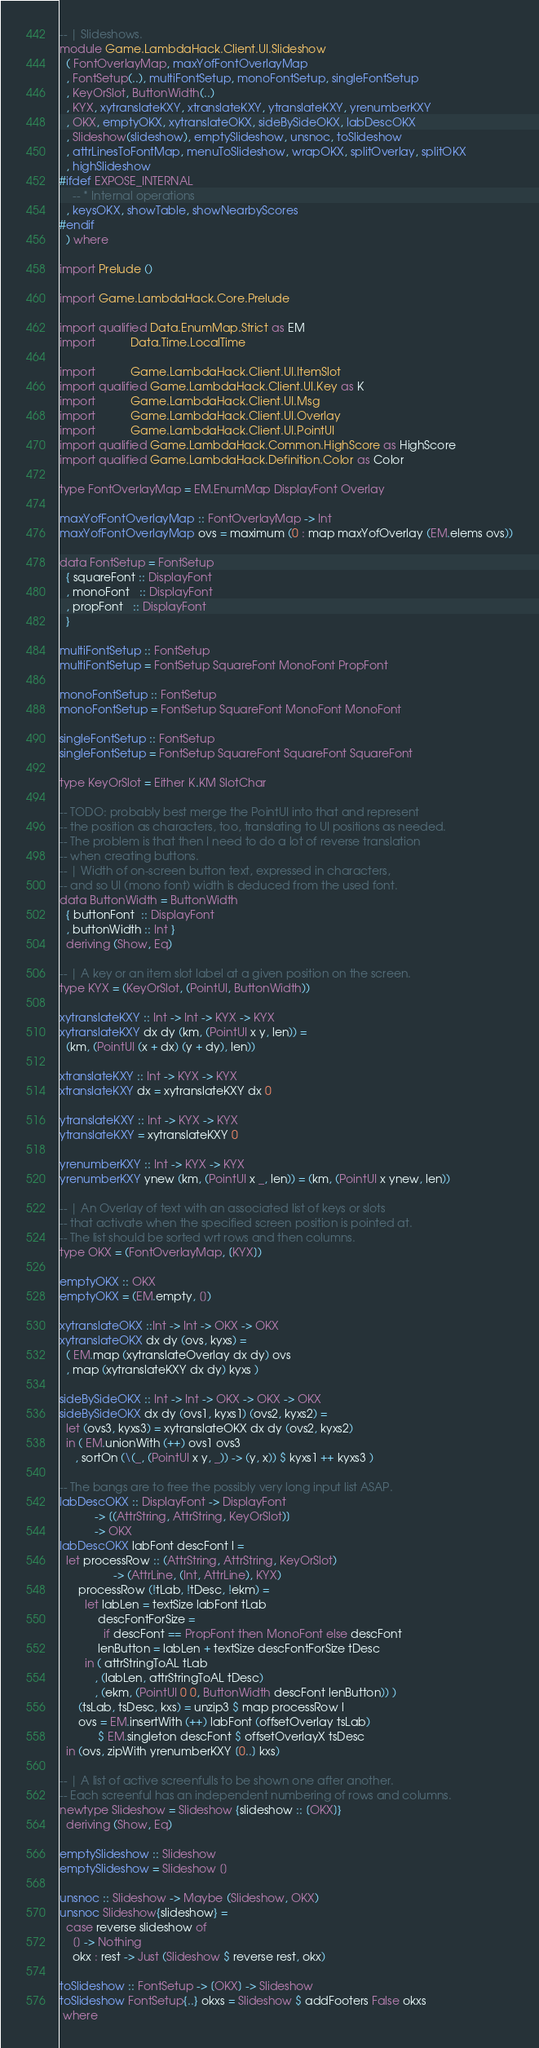Convert code to text. <code><loc_0><loc_0><loc_500><loc_500><_Haskell_>-- | Slideshows.
module Game.LambdaHack.Client.UI.Slideshow
  ( FontOverlayMap, maxYofFontOverlayMap
  , FontSetup(..), multiFontSetup, monoFontSetup, singleFontSetup
  , KeyOrSlot, ButtonWidth(..)
  , KYX, xytranslateKXY, xtranslateKXY, ytranslateKXY, yrenumberKXY
  , OKX, emptyOKX, xytranslateOKX, sideBySideOKX, labDescOKX
  , Slideshow(slideshow), emptySlideshow, unsnoc, toSlideshow
  , attrLinesToFontMap, menuToSlideshow, wrapOKX, splitOverlay, splitOKX
  , highSlideshow
#ifdef EXPOSE_INTERNAL
    -- * Internal operations
  , keysOKX, showTable, showNearbyScores
#endif
  ) where

import Prelude ()

import Game.LambdaHack.Core.Prelude

import qualified Data.EnumMap.Strict as EM
import           Data.Time.LocalTime

import           Game.LambdaHack.Client.UI.ItemSlot
import qualified Game.LambdaHack.Client.UI.Key as K
import           Game.LambdaHack.Client.UI.Msg
import           Game.LambdaHack.Client.UI.Overlay
import           Game.LambdaHack.Client.UI.PointUI
import qualified Game.LambdaHack.Common.HighScore as HighScore
import qualified Game.LambdaHack.Definition.Color as Color

type FontOverlayMap = EM.EnumMap DisplayFont Overlay

maxYofFontOverlayMap :: FontOverlayMap -> Int
maxYofFontOverlayMap ovs = maximum (0 : map maxYofOverlay (EM.elems ovs))

data FontSetup = FontSetup
  { squareFont :: DisplayFont
  , monoFont   :: DisplayFont
  , propFont   :: DisplayFont
  }

multiFontSetup :: FontSetup
multiFontSetup = FontSetup SquareFont MonoFont PropFont

monoFontSetup :: FontSetup
monoFontSetup = FontSetup SquareFont MonoFont MonoFont

singleFontSetup :: FontSetup
singleFontSetup = FontSetup SquareFont SquareFont SquareFont

type KeyOrSlot = Either K.KM SlotChar

-- TODO: probably best merge the PointUI into that and represent
-- the position as characters, too, translating to UI positions as needed.
-- The problem is that then I need to do a lot of reverse translation
-- when creating buttons.
-- | Width of on-screen button text, expressed in characters,
-- and so UI (mono font) width is deduced from the used font.
data ButtonWidth = ButtonWidth
  { buttonFont  :: DisplayFont
  , buttonWidth :: Int }
  deriving (Show, Eq)

-- | A key or an item slot label at a given position on the screen.
type KYX = (KeyOrSlot, (PointUI, ButtonWidth))

xytranslateKXY :: Int -> Int -> KYX -> KYX
xytranslateKXY dx dy (km, (PointUI x y, len)) =
  (km, (PointUI (x + dx) (y + dy), len))

xtranslateKXY :: Int -> KYX -> KYX
xtranslateKXY dx = xytranslateKXY dx 0

ytranslateKXY :: Int -> KYX -> KYX
ytranslateKXY = xytranslateKXY 0

yrenumberKXY :: Int -> KYX -> KYX
yrenumberKXY ynew (km, (PointUI x _, len)) = (km, (PointUI x ynew, len))

-- | An Overlay of text with an associated list of keys or slots
-- that activate when the specified screen position is pointed at.
-- The list should be sorted wrt rows and then columns.
type OKX = (FontOverlayMap, [KYX])

emptyOKX :: OKX
emptyOKX = (EM.empty, [])

xytranslateOKX ::Int -> Int -> OKX -> OKX
xytranslateOKX dx dy (ovs, kyxs) =
  ( EM.map (xytranslateOverlay dx dy) ovs
  , map (xytranslateKXY dx dy) kyxs )

sideBySideOKX :: Int -> Int -> OKX -> OKX -> OKX
sideBySideOKX dx dy (ovs1, kyxs1) (ovs2, kyxs2) =
  let (ovs3, kyxs3) = xytranslateOKX dx dy (ovs2, kyxs2)
  in ( EM.unionWith (++) ovs1 ovs3
     , sortOn (\(_, (PointUI x y, _)) -> (y, x)) $ kyxs1 ++ kyxs3 )

-- The bangs are to free the possibly very long input list ASAP.
labDescOKX :: DisplayFont -> DisplayFont
           -> [(AttrString, AttrString, KeyOrSlot)]
           -> OKX
labDescOKX labFont descFont l =
  let processRow :: (AttrString, AttrString, KeyOrSlot)
                 -> (AttrLine, (Int, AttrLine), KYX)
      processRow (!tLab, !tDesc, !ekm) =
        let labLen = textSize labFont tLab
            descFontForSize =
              if descFont == PropFont then MonoFont else descFont
            lenButton = labLen + textSize descFontForSize tDesc
        in ( attrStringToAL tLab
           , (labLen, attrStringToAL tDesc)
           , (ekm, (PointUI 0 0, ButtonWidth descFont lenButton)) )
      (tsLab, tsDesc, kxs) = unzip3 $ map processRow l
      ovs = EM.insertWith (++) labFont (offsetOverlay tsLab)
            $ EM.singleton descFont $ offsetOverlayX tsDesc
  in (ovs, zipWith yrenumberKXY [0..] kxs)

-- | A list of active screenfulls to be shown one after another.
-- Each screenful has an independent numbering of rows and columns.
newtype Slideshow = Slideshow {slideshow :: [OKX]}
  deriving (Show, Eq)

emptySlideshow :: Slideshow
emptySlideshow = Slideshow []

unsnoc :: Slideshow -> Maybe (Slideshow, OKX)
unsnoc Slideshow{slideshow} =
  case reverse slideshow of
    [] -> Nothing
    okx : rest -> Just (Slideshow $ reverse rest, okx)

toSlideshow :: FontSetup -> [OKX] -> Slideshow
toSlideshow FontSetup{..} okxs = Slideshow $ addFooters False okxs
 where</code> 